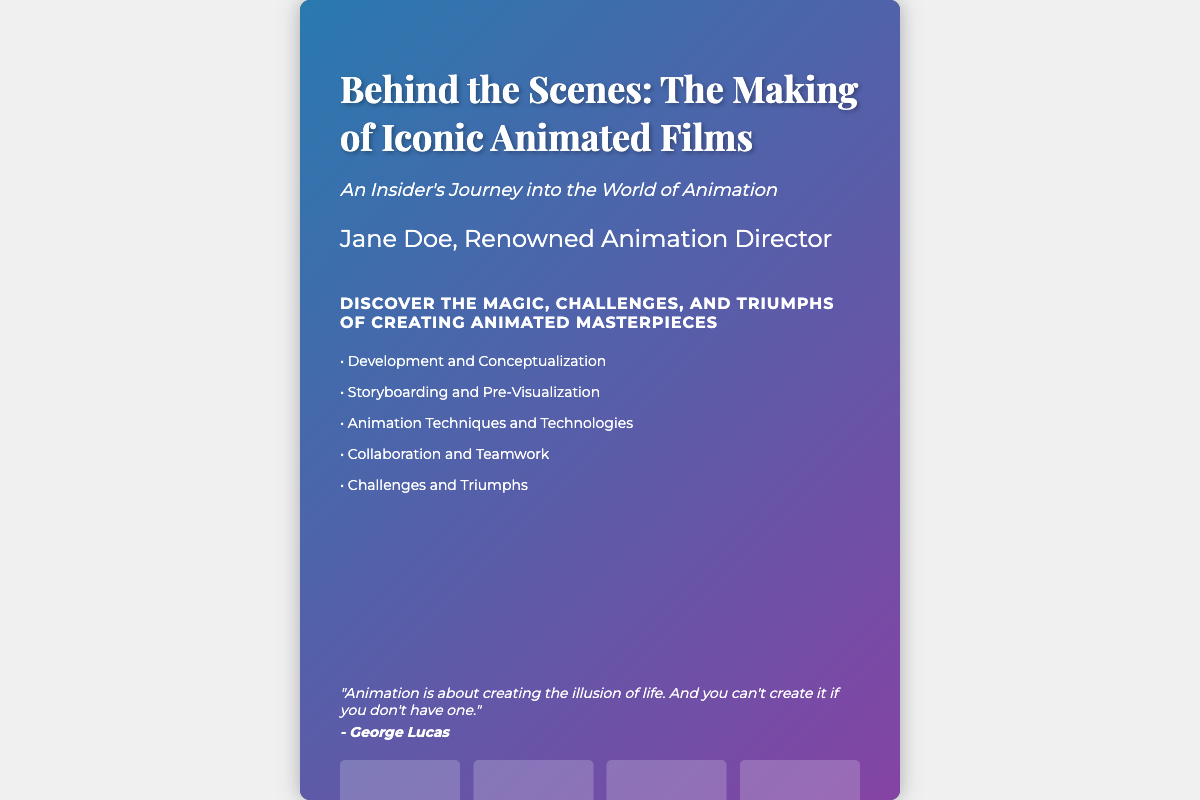What is the title of the book? The title of the book is prominently displayed at the top of the cover.
Answer: Behind the Scenes: The Making of Iconic Animated Films Who is the author of the book? The author's name is mentioned below the title on the cover.
Answer: Jane Doe, Renowned Animation Director What is the subtitle of the book? The subtitle provides additional context about the book's content.
Answer: An Insider's Journey into the World of Animation How many highlights are listed on the cover? The number of bullet points under highlights indicates the different topics covered.
Answer: Five What quote is featured on the cover? The quote is included as an inspirational message on the cover.
Answer: "Animation is about creating the illusion of life. And you can't create it if you don't have one." What is the theme of the tagline? The tagline summarizes the key themes explored in the book.
Answer: Magic, Challenges, and Triumphs of Creating Animated Masterpieces What are the colors used in the book cover's background? The background uses a specific color palette designed for visual appeal.
Answer: Dark Blue and Purple What is the font used for the title? The title is presented in a specific font style, emphasizing its importance.
Answer: Playfair Display What design element is used for the overlay? The overlay adds visual depth to the book cover's design.
Answer: Linear Gradient How many images are arranged on the cover? The images section shows how many visuals are included in the cover design.
Answer: Four 